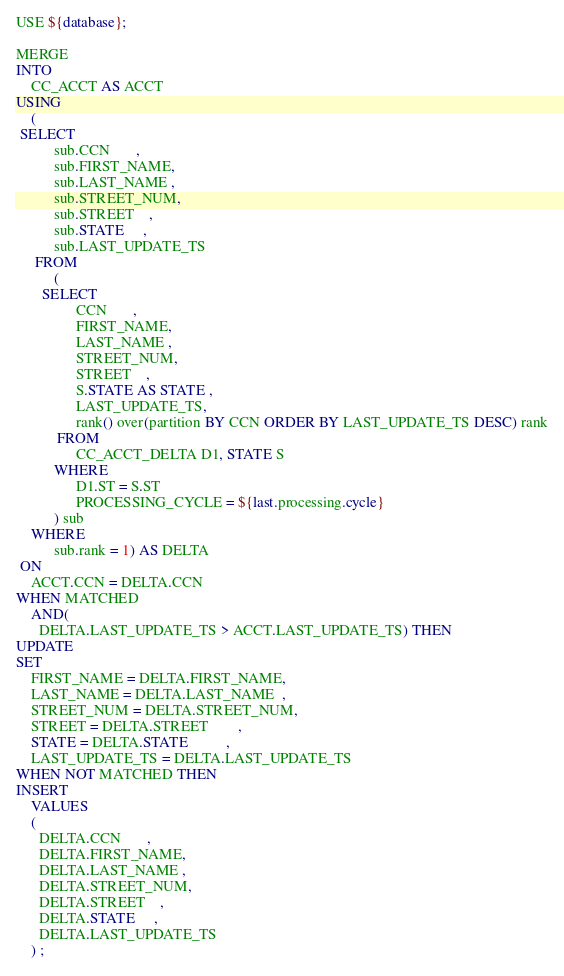<code> <loc_0><loc_0><loc_500><loc_500><_SQL_>USE ${database};

MERGE
INTO
    CC_ACCT AS ACCT
USING
    (
 SELECT
          sub.CCN       ,
          sub.FIRST_NAME,
          sub.LAST_NAME ,
          sub.STREET_NUM,
          sub.STREET    ,
          sub.STATE     ,
          sub.LAST_UPDATE_TS
     FROM
          (
       SELECT
                CCN       ,
                FIRST_NAME,
                LAST_NAME ,
                STREET_NUM,
                STREET    ,
                S.STATE AS STATE ,
                LAST_UPDATE_TS,
                rank() over(partition BY CCN ORDER BY LAST_UPDATE_TS DESC) rank
           FROM
                CC_ACCT_DELTA D1, STATE S
          WHERE
                D1.ST = S.ST
                PROCESSING_CYCLE = ${last.processing.cycle}
          ) sub
    WHERE
          sub.rank = 1) AS DELTA
 ON
    ACCT.CCN = DELTA.CCN
WHEN MATCHED
    AND(
      DELTA.LAST_UPDATE_TS > ACCT.LAST_UPDATE_TS) THEN
UPDATE
SET
    FIRST_NAME = DELTA.FIRST_NAME,
    LAST_NAME = DELTA.LAST_NAME  ,
    STREET_NUM = DELTA.STREET_NUM,
    STREET = DELTA.STREET        ,
    STATE = DELTA.STATE          ,
    LAST_UPDATE_TS = DELTA.LAST_UPDATE_TS 
WHEN NOT MATCHED THEN
INSERT
    VALUES
    (
      DELTA.CCN       ,
      DELTA.FIRST_NAME,
      DELTA.LAST_NAME ,
      DELTA.STREET_NUM,
      DELTA.STREET    ,
      DELTA.STATE     ,
      DELTA.LAST_UPDATE_TS
    ) ;</code> 